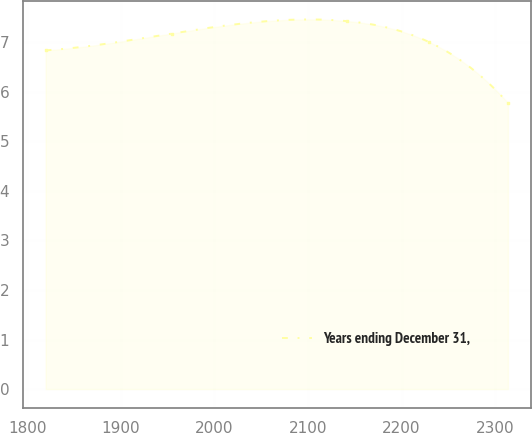Convert chart to OTSL. <chart><loc_0><loc_0><loc_500><loc_500><line_chart><ecel><fcel>Years ending December 31,<nl><fcel>1819.71<fcel>6.83<nl><fcel>1954.48<fcel>7.17<nl><fcel>2141.6<fcel>7.42<nl><fcel>2229.11<fcel>7<nl><fcel>2313.6<fcel>5.77<nl></chart> 